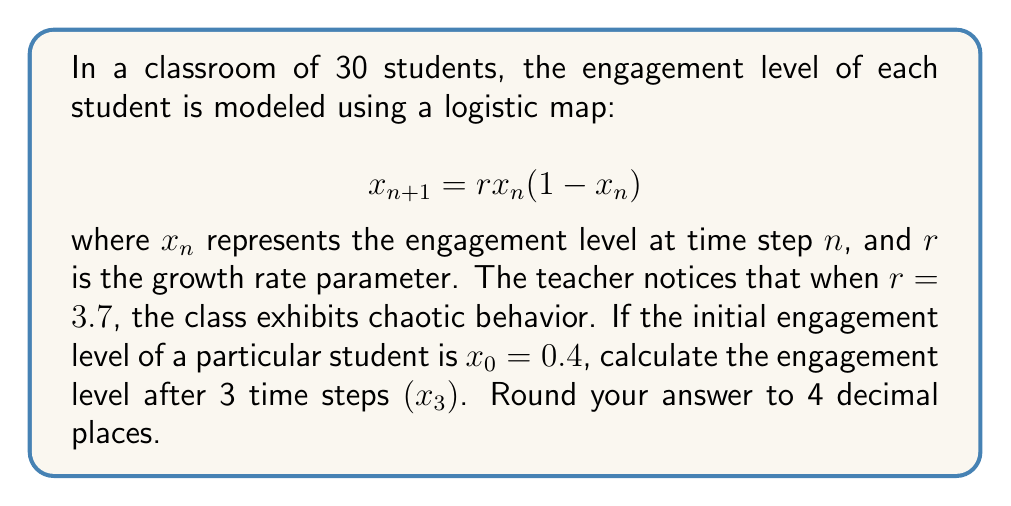Help me with this question. To solve this problem, we need to iterate the logistic map equation three times:

Step 1: Calculate $x_1$
$$x_1 = r \cdot x_0(1-x_0)$$
$$x_1 = 3.7 \cdot 0.4(1-0.4)$$
$$x_1 = 3.7 \cdot 0.4 \cdot 0.6 = 0.888$$

Step 2: Calculate $x_2$
$$x_2 = r \cdot x_1(1-x_1)$$
$$x_2 = 3.7 \cdot 0.888(1-0.888)$$
$$x_2 = 3.7 \cdot 0.888 \cdot 0.112 = 0.3682752$$

Step 3: Calculate $x_3$
$$x_3 = r \cdot x_2(1-x_2)$$
$$x_3 = 3.7 \cdot 0.3682752(1-0.3682752)$$
$$x_3 = 3.7 \cdot 0.3682752 \cdot 0.6317248 \approx 0.8626$$

Rounding to 4 decimal places, we get $x_3 = 0.8626$.

This result demonstrates how quickly the engagement level can change in a chaotic system, even with a deterministic model. Such unpredictability highlights the complexity of classroom dynamics and the need for adaptive teaching strategies.
Answer: 0.8626 